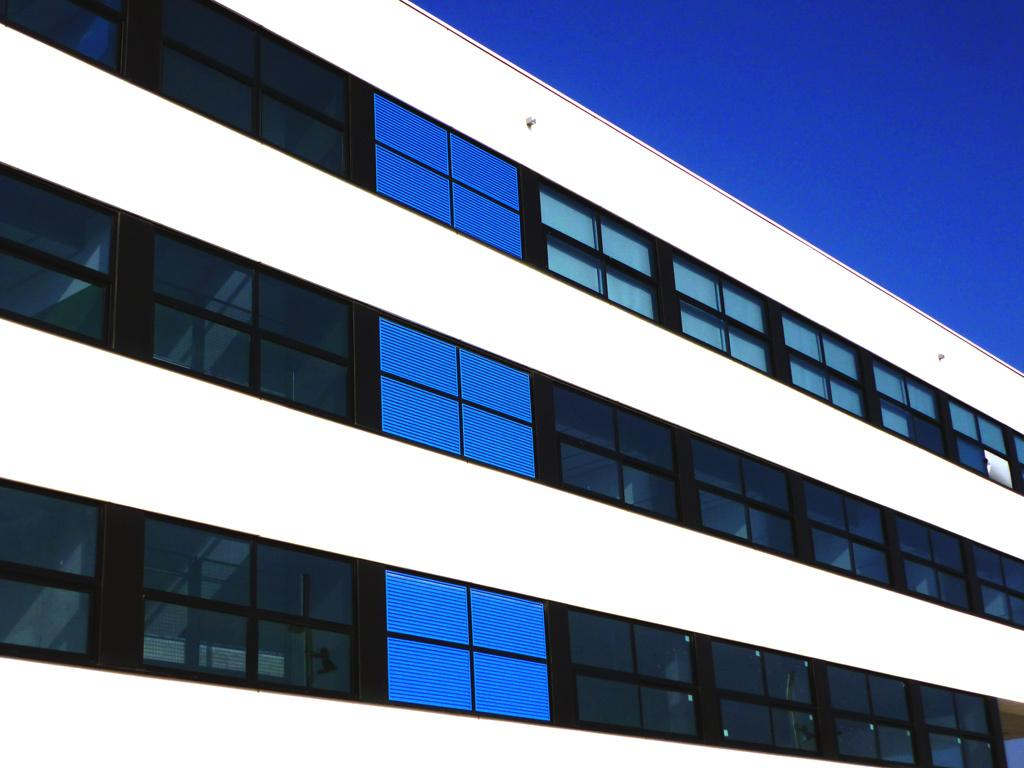What type of structure is present in the image? There is a building in the image. What is the color of the building? The building is white in color. What feature can be observed on the building? The building has glass windows. What colors are the glass windows? The glass windows are blue and grey in color. What is visible in the background of the image? The sky is visible in the image. What is the color of the sky? The sky is blue in color. Can you see the brain of the snail in the image? There is no snail or brain present in the image; it features a white building with blue and grey glass windows and a blue sky. 